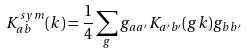Convert formula to latex. <formula><loc_0><loc_0><loc_500><loc_500>K _ { a b } ^ { s y m } ( { k } ) = \frac { 1 } { 4 } \sum _ { g } g _ { a a ^ { \prime } } K _ { a ^ { \prime } b ^ { \prime } } ( g { k } ) g _ { b b ^ { \prime } }</formula> 